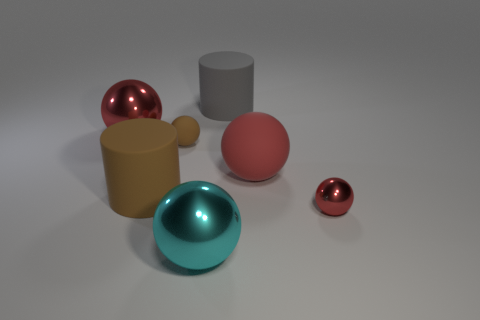Subtract all large red matte balls. How many balls are left? 4 Add 3 red metallic spheres. How many objects exist? 10 Subtract all balls. How many objects are left? 2 Subtract 2 cylinders. How many cylinders are left? 0 Subtract all brown cylinders. Subtract all blue spheres. How many cylinders are left? 1 Subtract all red spheres. How many gray cylinders are left? 1 Subtract all red objects. Subtract all brown matte cylinders. How many objects are left? 3 Add 1 balls. How many balls are left? 6 Add 2 big blue shiny balls. How many big blue shiny balls exist? 2 Subtract all brown spheres. How many spheres are left? 4 